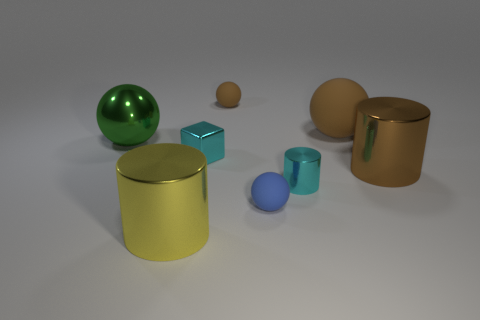Subtract all brown cylinders. How many brown balls are left? 2 Subtract all green metallic balls. How many balls are left? 3 Subtract all green spheres. How many spheres are left? 3 Add 2 large green metallic balls. How many objects exist? 10 Subtract all blue balls. Subtract all green cylinders. How many balls are left? 3 Subtract all cylinders. How many objects are left? 5 Add 7 large cylinders. How many large cylinders are left? 9 Add 2 shiny objects. How many shiny objects exist? 7 Subtract 1 cyan cylinders. How many objects are left? 7 Subtract all large yellow cylinders. Subtract all tiny brown balls. How many objects are left? 6 